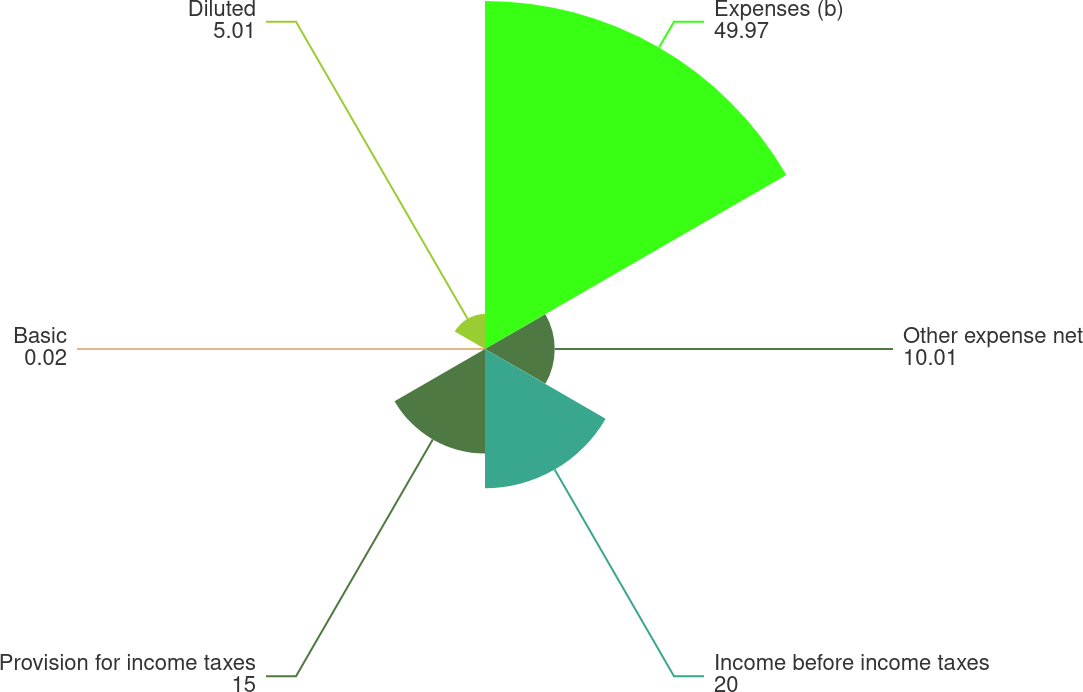Convert chart. <chart><loc_0><loc_0><loc_500><loc_500><pie_chart><fcel>Expenses (b)<fcel>Other expense net<fcel>Income before income taxes<fcel>Provision for income taxes<fcel>Basic<fcel>Diluted<nl><fcel>49.97%<fcel>10.01%<fcel>20.0%<fcel>15.0%<fcel>0.02%<fcel>5.01%<nl></chart> 